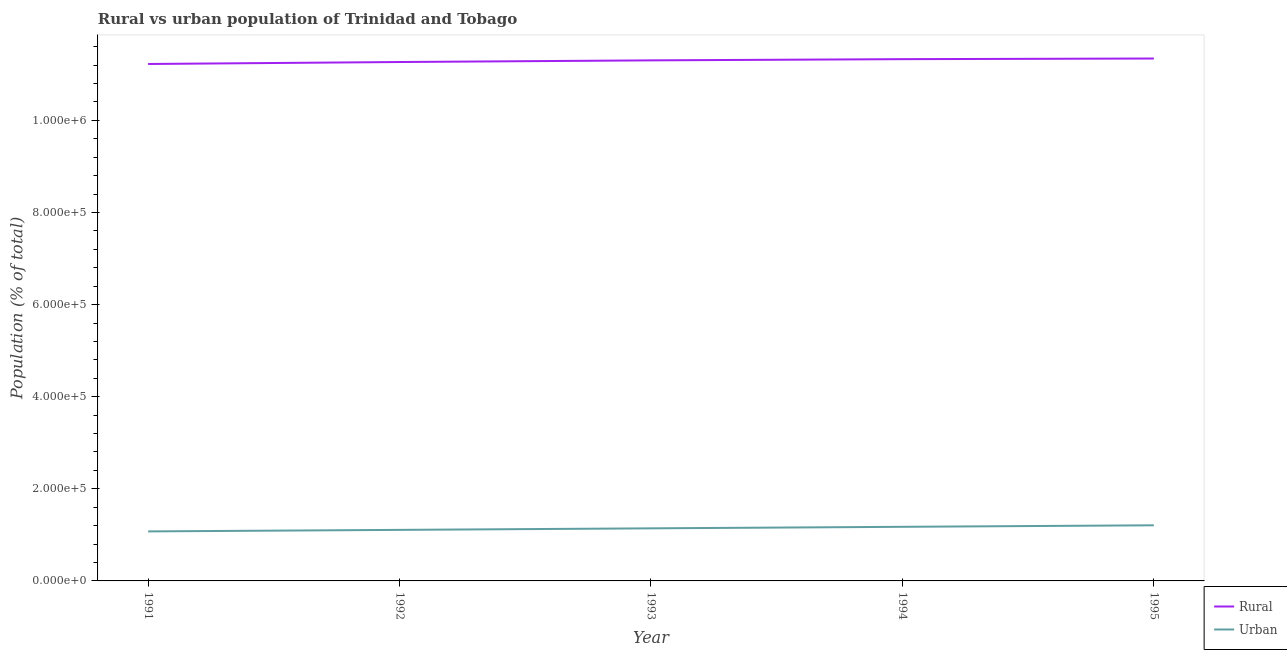Does the line corresponding to rural population density intersect with the line corresponding to urban population density?
Offer a terse response. No. What is the rural population density in 1994?
Give a very brief answer. 1.13e+06. Across all years, what is the maximum urban population density?
Offer a terse response. 1.21e+05. Across all years, what is the minimum rural population density?
Ensure brevity in your answer.  1.12e+06. In which year was the urban population density maximum?
Your answer should be very brief. 1995. In which year was the urban population density minimum?
Make the answer very short. 1991. What is the total urban population density in the graph?
Provide a succinct answer. 5.71e+05. What is the difference between the rural population density in 1992 and that in 1993?
Make the answer very short. -3591. What is the difference between the rural population density in 1991 and the urban population density in 1995?
Your answer should be very brief. 1.00e+06. What is the average rural population density per year?
Your answer should be compact. 1.13e+06. In the year 1993, what is the difference between the rural population density and urban population density?
Your answer should be compact. 1.02e+06. In how many years, is the rural population density greater than 520000 %?
Your response must be concise. 5. What is the ratio of the urban population density in 1992 to that in 1995?
Offer a terse response. 0.92. Is the urban population density in 1992 less than that in 1994?
Ensure brevity in your answer.  Yes. What is the difference between the highest and the second highest rural population density?
Your answer should be very brief. 1396. What is the difference between the highest and the lowest rural population density?
Keep it short and to the point. 1.19e+04. In how many years, is the rural population density greater than the average rural population density taken over all years?
Your response must be concise. 3. Is the sum of the urban population density in 1991 and 1993 greater than the maximum rural population density across all years?
Give a very brief answer. No. Does the rural population density monotonically increase over the years?
Offer a terse response. Yes. Is the rural population density strictly greater than the urban population density over the years?
Your answer should be very brief. Yes. Is the rural population density strictly less than the urban population density over the years?
Provide a succinct answer. No. How many years are there in the graph?
Give a very brief answer. 5. What is the difference between two consecutive major ticks on the Y-axis?
Offer a very short reply. 2.00e+05. Are the values on the major ticks of Y-axis written in scientific E-notation?
Your answer should be compact. Yes. Does the graph contain any zero values?
Provide a succinct answer. No. Does the graph contain grids?
Your response must be concise. No. How are the legend labels stacked?
Give a very brief answer. Vertical. What is the title of the graph?
Provide a short and direct response. Rural vs urban population of Trinidad and Tobago. Does "Methane" appear as one of the legend labels in the graph?
Provide a short and direct response. No. What is the label or title of the X-axis?
Offer a terse response. Year. What is the label or title of the Y-axis?
Make the answer very short. Population (% of total). What is the Population (% of total) of Rural in 1991?
Provide a succinct answer. 1.12e+06. What is the Population (% of total) in Urban in 1991?
Make the answer very short. 1.08e+05. What is the Population (% of total) in Rural in 1992?
Make the answer very short. 1.13e+06. What is the Population (% of total) in Urban in 1992?
Make the answer very short. 1.11e+05. What is the Population (% of total) of Rural in 1993?
Provide a short and direct response. 1.13e+06. What is the Population (% of total) of Urban in 1993?
Offer a terse response. 1.14e+05. What is the Population (% of total) in Rural in 1994?
Your answer should be compact. 1.13e+06. What is the Population (% of total) in Urban in 1994?
Ensure brevity in your answer.  1.17e+05. What is the Population (% of total) of Rural in 1995?
Offer a very short reply. 1.13e+06. What is the Population (% of total) of Urban in 1995?
Provide a succinct answer. 1.21e+05. Across all years, what is the maximum Population (% of total) in Rural?
Make the answer very short. 1.13e+06. Across all years, what is the maximum Population (% of total) in Urban?
Your answer should be compact. 1.21e+05. Across all years, what is the minimum Population (% of total) of Rural?
Make the answer very short. 1.12e+06. Across all years, what is the minimum Population (% of total) in Urban?
Ensure brevity in your answer.  1.08e+05. What is the total Population (% of total) of Rural in the graph?
Your answer should be very brief. 5.65e+06. What is the total Population (% of total) in Urban in the graph?
Make the answer very short. 5.71e+05. What is the difference between the Population (% of total) of Rural in 1991 and that in 1992?
Your response must be concise. -4281. What is the difference between the Population (% of total) in Urban in 1991 and that in 1992?
Provide a succinct answer. -3299. What is the difference between the Population (% of total) of Rural in 1991 and that in 1993?
Your answer should be very brief. -7872. What is the difference between the Population (% of total) in Urban in 1991 and that in 1993?
Your answer should be very brief. -6632. What is the difference between the Population (% of total) of Rural in 1991 and that in 1994?
Ensure brevity in your answer.  -1.05e+04. What is the difference between the Population (% of total) of Urban in 1991 and that in 1994?
Offer a terse response. -9949. What is the difference between the Population (% of total) of Rural in 1991 and that in 1995?
Your response must be concise. -1.19e+04. What is the difference between the Population (% of total) in Urban in 1991 and that in 1995?
Offer a very short reply. -1.32e+04. What is the difference between the Population (% of total) in Rural in 1992 and that in 1993?
Your answer should be compact. -3591. What is the difference between the Population (% of total) of Urban in 1992 and that in 1993?
Provide a succinct answer. -3333. What is the difference between the Population (% of total) in Rural in 1992 and that in 1994?
Provide a succinct answer. -6180. What is the difference between the Population (% of total) of Urban in 1992 and that in 1994?
Offer a terse response. -6650. What is the difference between the Population (% of total) in Rural in 1992 and that in 1995?
Provide a short and direct response. -7576. What is the difference between the Population (% of total) of Urban in 1992 and that in 1995?
Give a very brief answer. -9939. What is the difference between the Population (% of total) of Rural in 1993 and that in 1994?
Give a very brief answer. -2589. What is the difference between the Population (% of total) in Urban in 1993 and that in 1994?
Offer a terse response. -3317. What is the difference between the Population (% of total) in Rural in 1993 and that in 1995?
Give a very brief answer. -3985. What is the difference between the Population (% of total) of Urban in 1993 and that in 1995?
Offer a terse response. -6606. What is the difference between the Population (% of total) of Rural in 1994 and that in 1995?
Offer a very short reply. -1396. What is the difference between the Population (% of total) in Urban in 1994 and that in 1995?
Ensure brevity in your answer.  -3289. What is the difference between the Population (% of total) in Rural in 1991 and the Population (% of total) in Urban in 1992?
Your answer should be very brief. 1.01e+06. What is the difference between the Population (% of total) of Rural in 1991 and the Population (% of total) of Urban in 1993?
Offer a very short reply. 1.01e+06. What is the difference between the Population (% of total) of Rural in 1991 and the Population (% of total) of Urban in 1994?
Your answer should be compact. 1.00e+06. What is the difference between the Population (% of total) of Rural in 1991 and the Population (% of total) of Urban in 1995?
Your response must be concise. 1.00e+06. What is the difference between the Population (% of total) of Rural in 1992 and the Population (% of total) of Urban in 1993?
Make the answer very short. 1.01e+06. What is the difference between the Population (% of total) of Rural in 1992 and the Population (% of total) of Urban in 1994?
Give a very brief answer. 1.01e+06. What is the difference between the Population (% of total) in Rural in 1992 and the Population (% of total) in Urban in 1995?
Provide a succinct answer. 1.01e+06. What is the difference between the Population (% of total) of Rural in 1993 and the Population (% of total) of Urban in 1994?
Make the answer very short. 1.01e+06. What is the difference between the Population (% of total) in Rural in 1993 and the Population (% of total) in Urban in 1995?
Ensure brevity in your answer.  1.01e+06. What is the difference between the Population (% of total) of Rural in 1994 and the Population (% of total) of Urban in 1995?
Provide a succinct answer. 1.01e+06. What is the average Population (% of total) of Rural per year?
Offer a very short reply. 1.13e+06. What is the average Population (% of total) of Urban per year?
Offer a very short reply. 1.14e+05. In the year 1991, what is the difference between the Population (% of total) in Rural and Population (% of total) in Urban?
Provide a succinct answer. 1.01e+06. In the year 1992, what is the difference between the Population (% of total) in Rural and Population (% of total) in Urban?
Keep it short and to the point. 1.02e+06. In the year 1993, what is the difference between the Population (% of total) of Rural and Population (% of total) of Urban?
Provide a succinct answer. 1.02e+06. In the year 1994, what is the difference between the Population (% of total) in Rural and Population (% of total) in Urban?
Offer a terse response. 1.02e+06. In the year 1995, what is the difference between the Population (% of total) in Rural and Population (% of total) in Urban?
Ensure brevity in your answer.  1.01e+06. What is the ratio of the Population (% of total) of Rural in 1991 to that in 1992?
Provide a short and direct response. 1. What is the ratio of the Population (% of total) in Urban in 1991 to that in 1992?
Your answer should be compact. 0.97. What is the ratio of the Population (% of total) in Rural in 1991 to that in 1993?
Give a very brief answer. 0.99. What is the ratio of the Population (% of total) in Urban in 1991 to that in 1993?
Provide a succinct answer. 0.94. What is the ratio of the Population (% of total) of Urban in 1991 to that in 1994?
Give a very brief answer. 0.92. What is the ratio of the Population (% of total) of Rural in 1991 to that in 1995?
Your response must be concise. 0.99. What is the ratio of the Population (% of total) in Urban in 1991 to that in 1995?
Your answer should be compact. 0.89. What is the ratio of the Population (% of total) in Urban in 1992 to that in 1993?
Keep it short and to the point. 0.97. What is the ratio of the Population (% of total) of Rural in 1992 to that in 1994?
Your answer should be very brief. 0.99. What is the ratio of the Population (% of total) in Urban in 1992 to that in 1994?
Make the answer very short. 0.94. What is the ratio of the Population (% of total) of Urban in 1992 to that in 1995?
Provide a short and direct response. 0.92. What is the ratio of the Population (% of total) of Urban in 1993 to that in 1994?
Make the answer very short. 0.97. What is the ratio of the Population (% of total) in Urban in 1993 to that in 1995?
Your response must be concise. 0.95. What is the ratio of the Population (% of total) of Urban in 1994 to that in 1995?
Make the answer very short. 0.97. What is the difference between the highest and the second highest Population (% of total) of Rural?
Your response must be concise. 1396. What is the difference between the highest and the second highest Population (% of total) in Urban?
Your answer should be compact. 3289. What is the difference between the highest and the lowest Population (% of total) in Rural?
Offer a terse response. 1.19e+04. What is the difference between the highest and the lowest Population (% of total) of Urban?
Provide a short and direct response. 1.32e+04. 